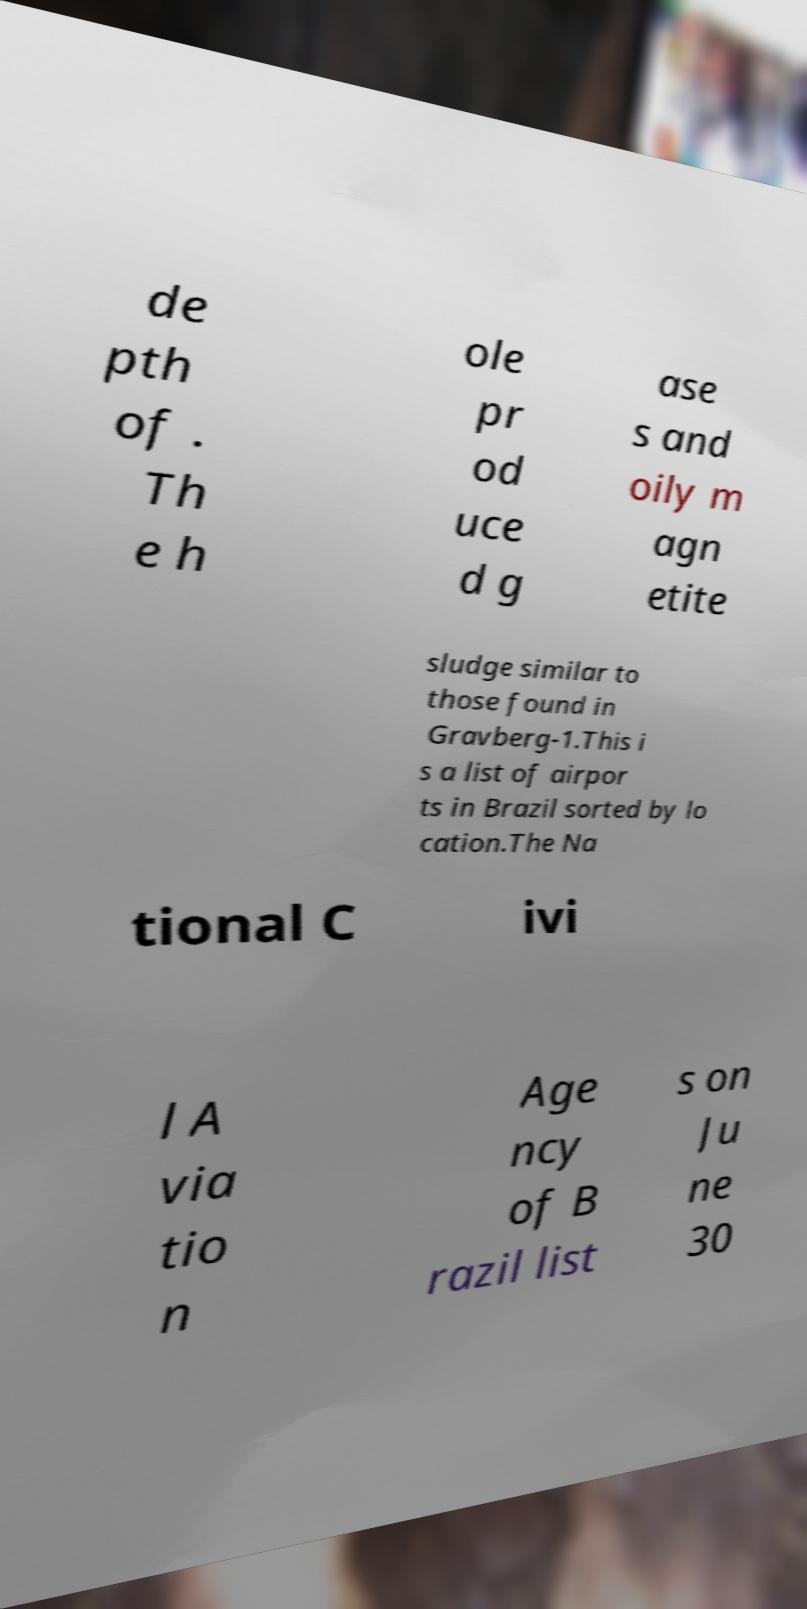For documentation purposes, I need the text within this image transcribed. Could you provide that? de pth of . Th e h ole pr od uce d g ase s and oily m agn etite sludge similar to those found in Gravberg-1.This i s a list of airpor ts in Brazil sorted by lo cation.The Na tional C ivi l A via tio n Age ncy of B razil list s on Ju ne 30 